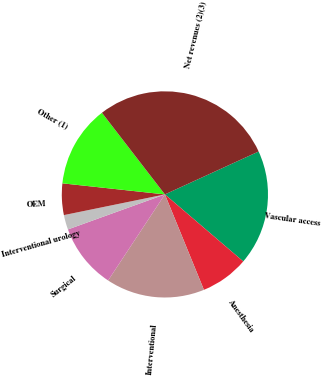<chart> <loc_0><loc_0><loc_500><loc_500><pie_chart><fcel>Vascular access<fcel>Anesthesia<fcel>Interventional<fcel>Surgical<fcel>Interventional urology<fcel>OEM<fcel>Other (1)<fcel>Net revenues (2)(3)<nl><fcel>18.09%<fcel>7.56%<fcel>15.46%<fcel>10.2%<fcel>2.3%<fcel>4.93%<fcel>12.83%<fcel>28.62%<nl></chart> 